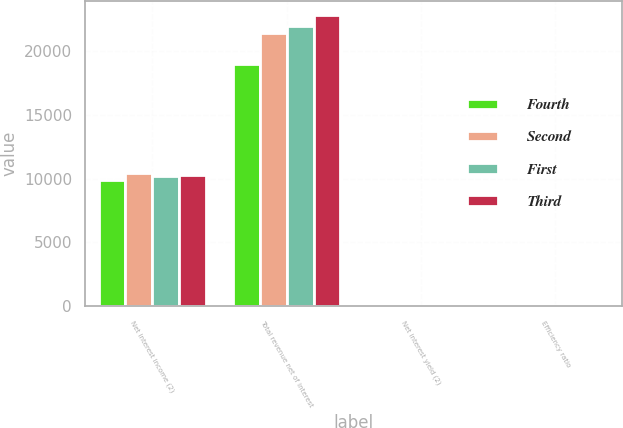Convert chart. <chart><loc_0><loc_0><loc_500><loc_500><stacked_bar_chart><ecel><fcel>Net interest income (2)<fcel>Total revenue net of interest<fcel>Net interest yield (2)<fcel>Efficiency ratio<nl><fcel>Fourth<fcel>9865<fcel>18955<fcel>2.18<fcel>74.9<nl><fcel>Second<fcel>10444<fcel>21434<fcel>2.29<fcel>93.97<nl><fcel>First<fcel>10226<fcel>21960<fcel>2.22<fcel>84.43<nl><fcel>Third<fcel>10286<fcel>22767<fcel>2.29<fcel>97.68<nl></chart> 